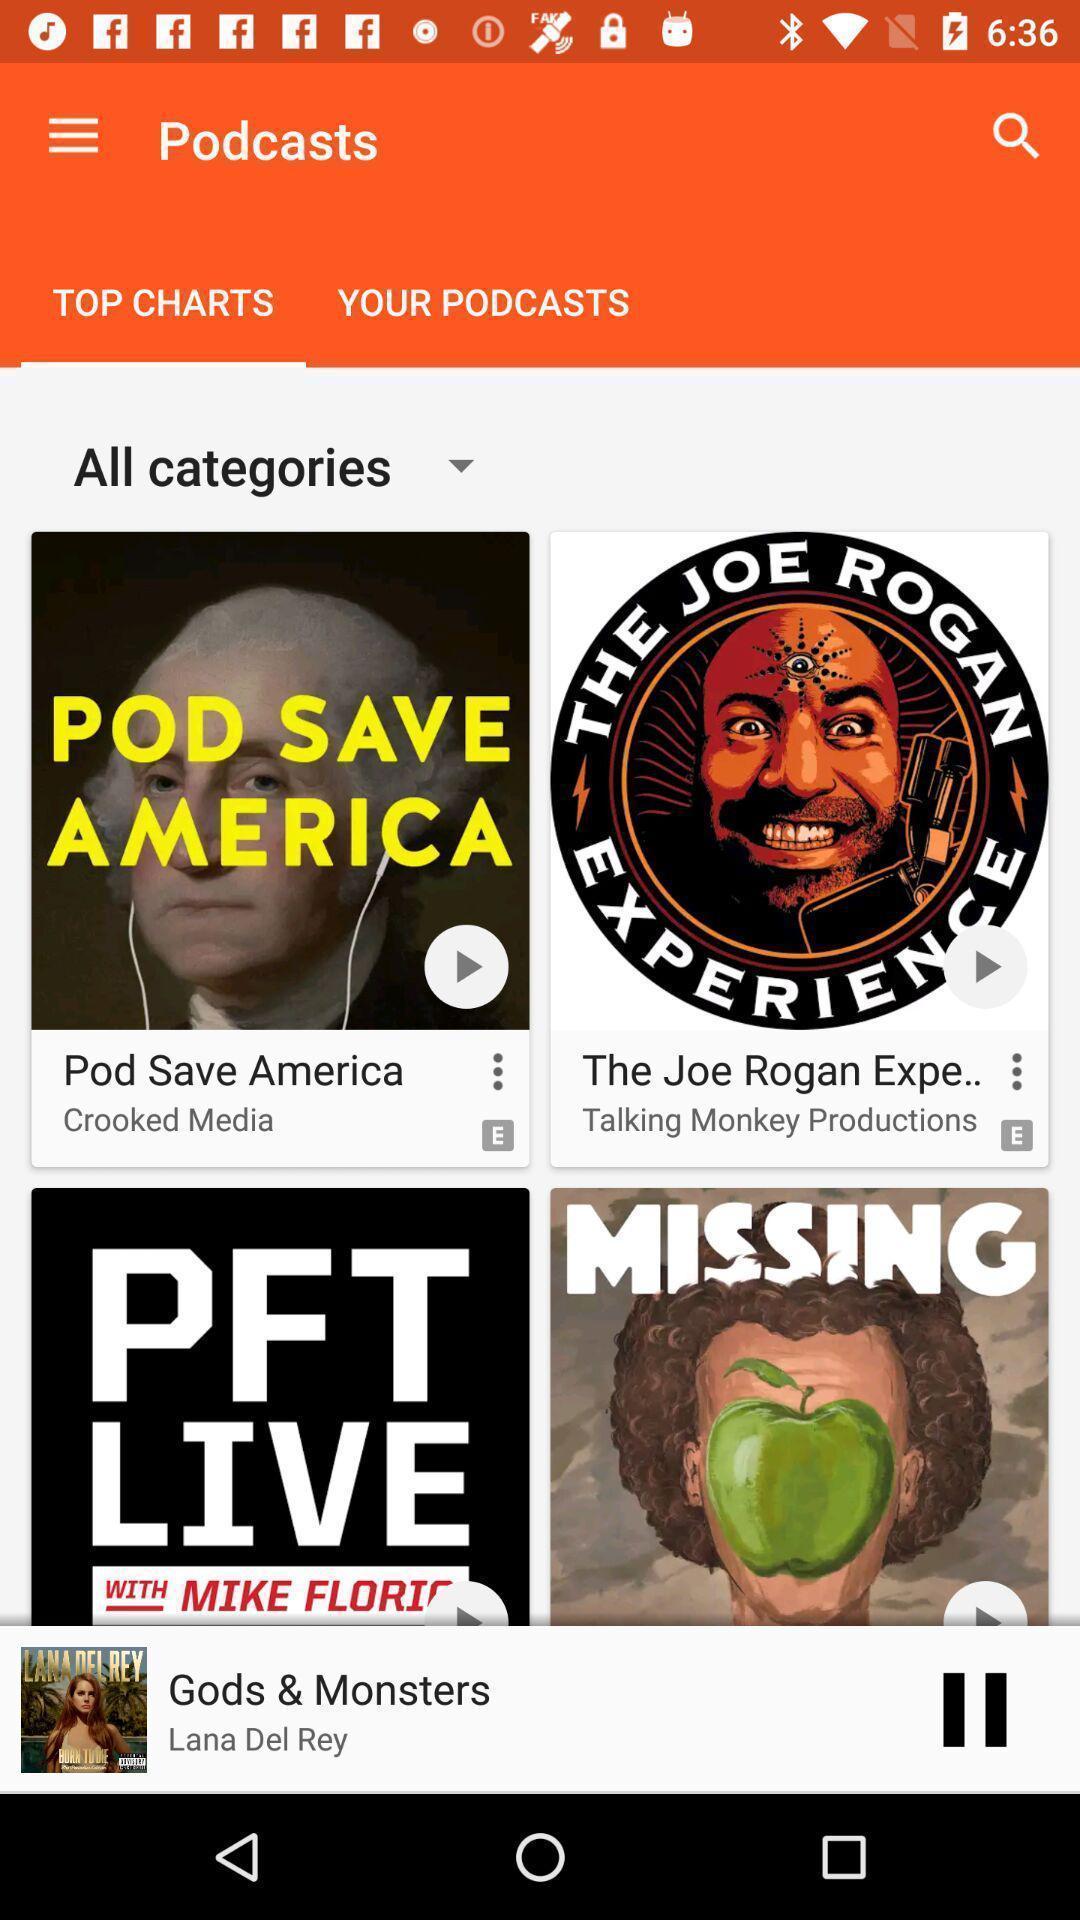Give me a summary of this screen capture. Page showing different categories. 